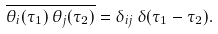Convert formula to latex. <formula><loc_0><loc_0><loc_500><loc_500>\overline { \theta _ { i } ( \tau _ { 1 } ) \, \theta _ { j } ( \tau _ { 2 } ) } = \delta _ { i j } \, \delta ( \tau _ { 1 } - \tau _ { 2 } ) .</formula> 